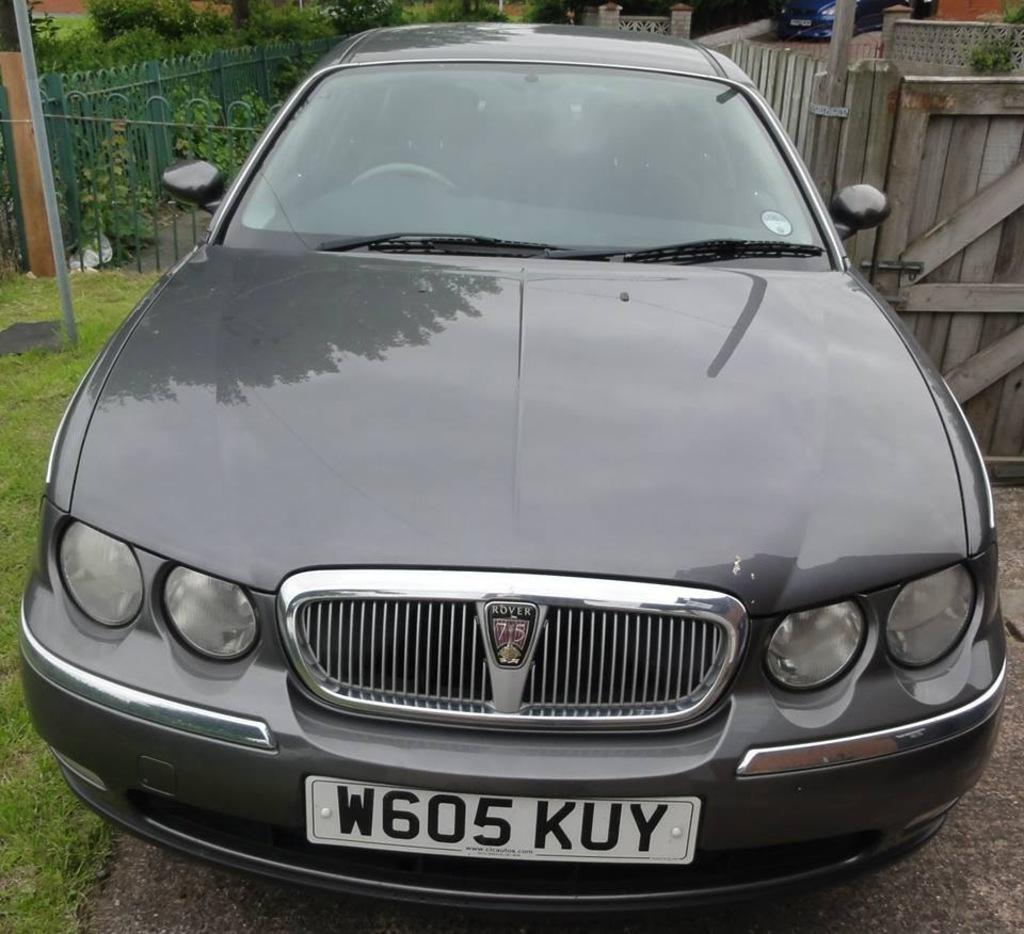<image>
Give a short and clear explanation of the subsequent image. A Rover car with a 75 emblem in front that has a license plate that reads W605 KUY. 